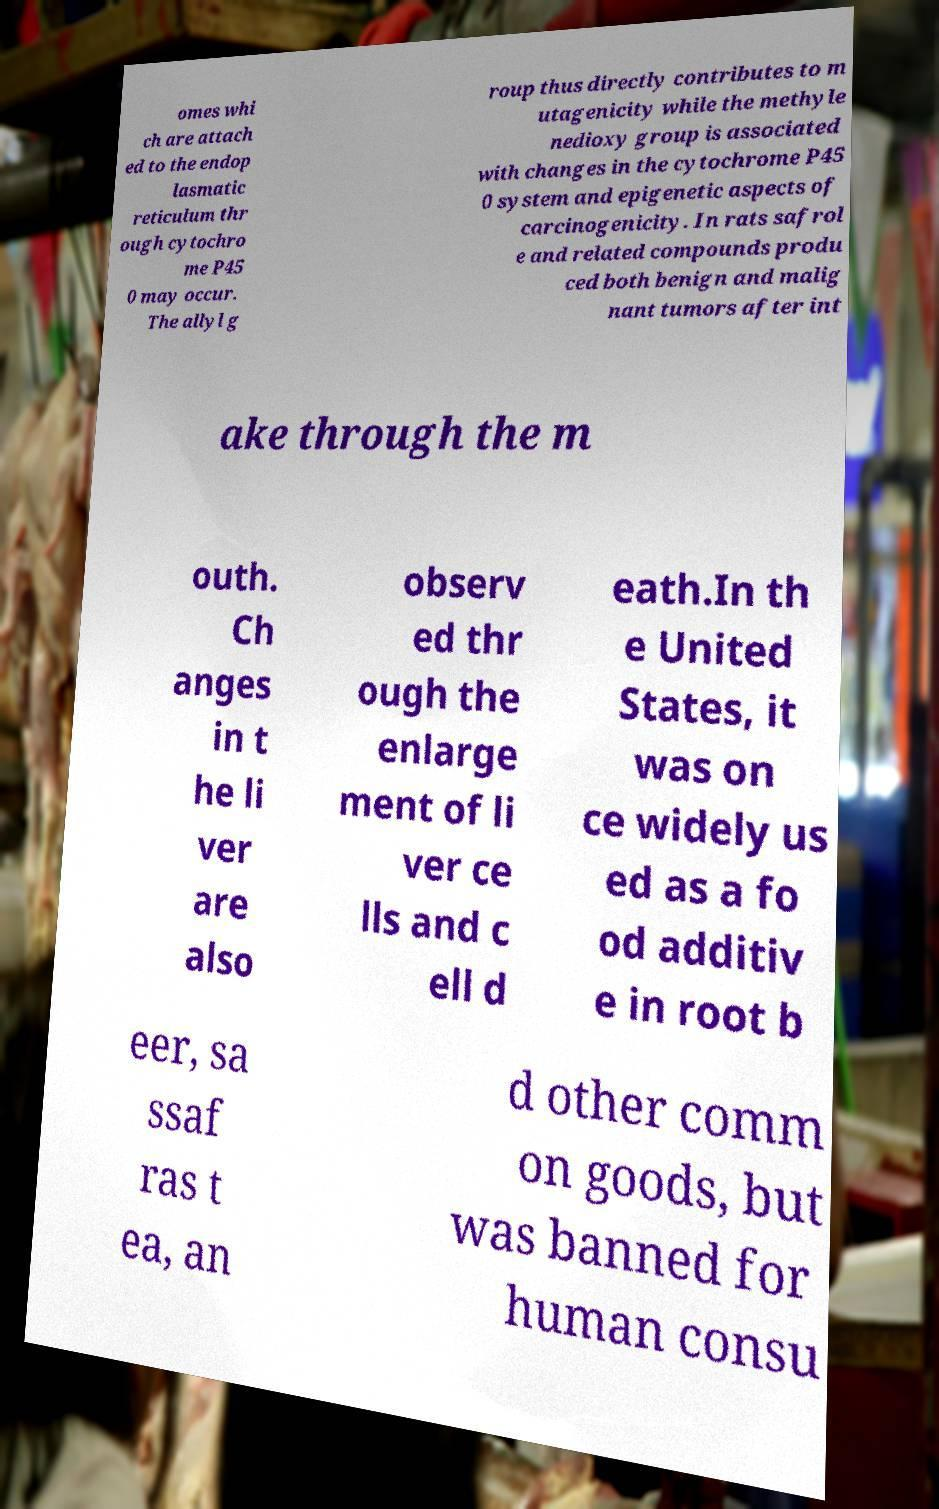Can you read and provide the text displayed in the image?This photo seems to have some interesting text. Can you extract and type it out for me? omes whi ch are attach ed to the endop lasmatic reticulum thr ough cytochro me P45 0 may occur. The allyl g roup thus directly contributes to m utagenicity while the methyle nedioxy group is associated with changes in the cytochrome P45 0 system and epigenetic aspects of carcinogenicity. In rats safrol e and related compounds produ ced both benign and malig nant tumors after int ake through the m outh. Ch anges in t he li ver are also observ ed thr ough the enlarge ment of li ver ce lls and c ell d eath.In th e United States, it was on ce widely us ed as a fo od additiv e in root b eer, sa ssaf ras t ea, an d other comm on goods, but was banned for human consu 